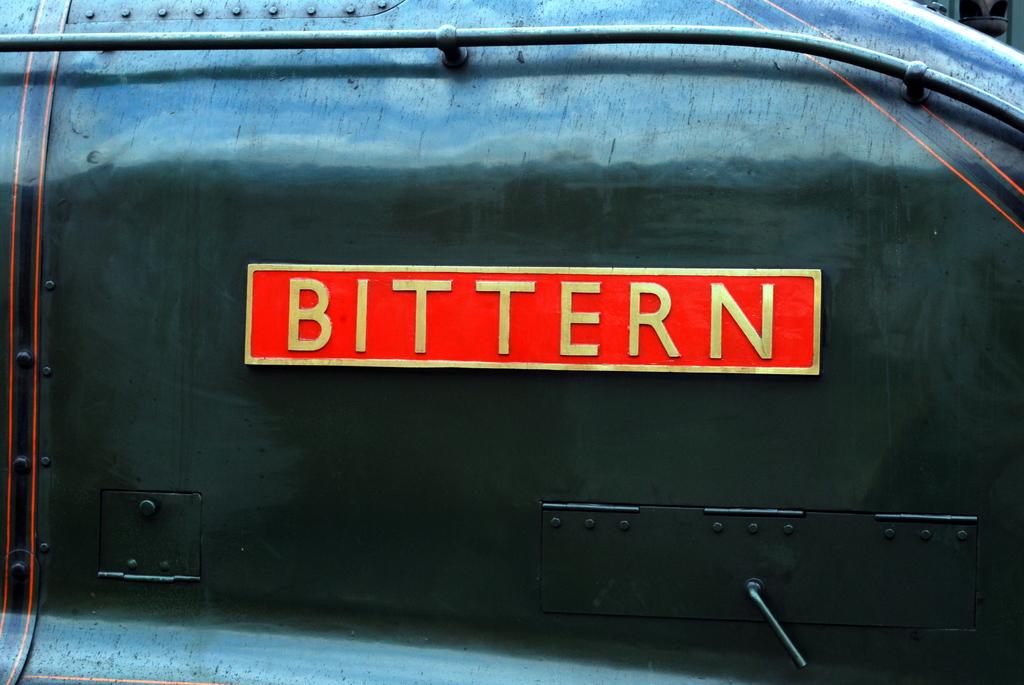What does the red sign say?
Ensure brevity in your answer.  Bittern. 